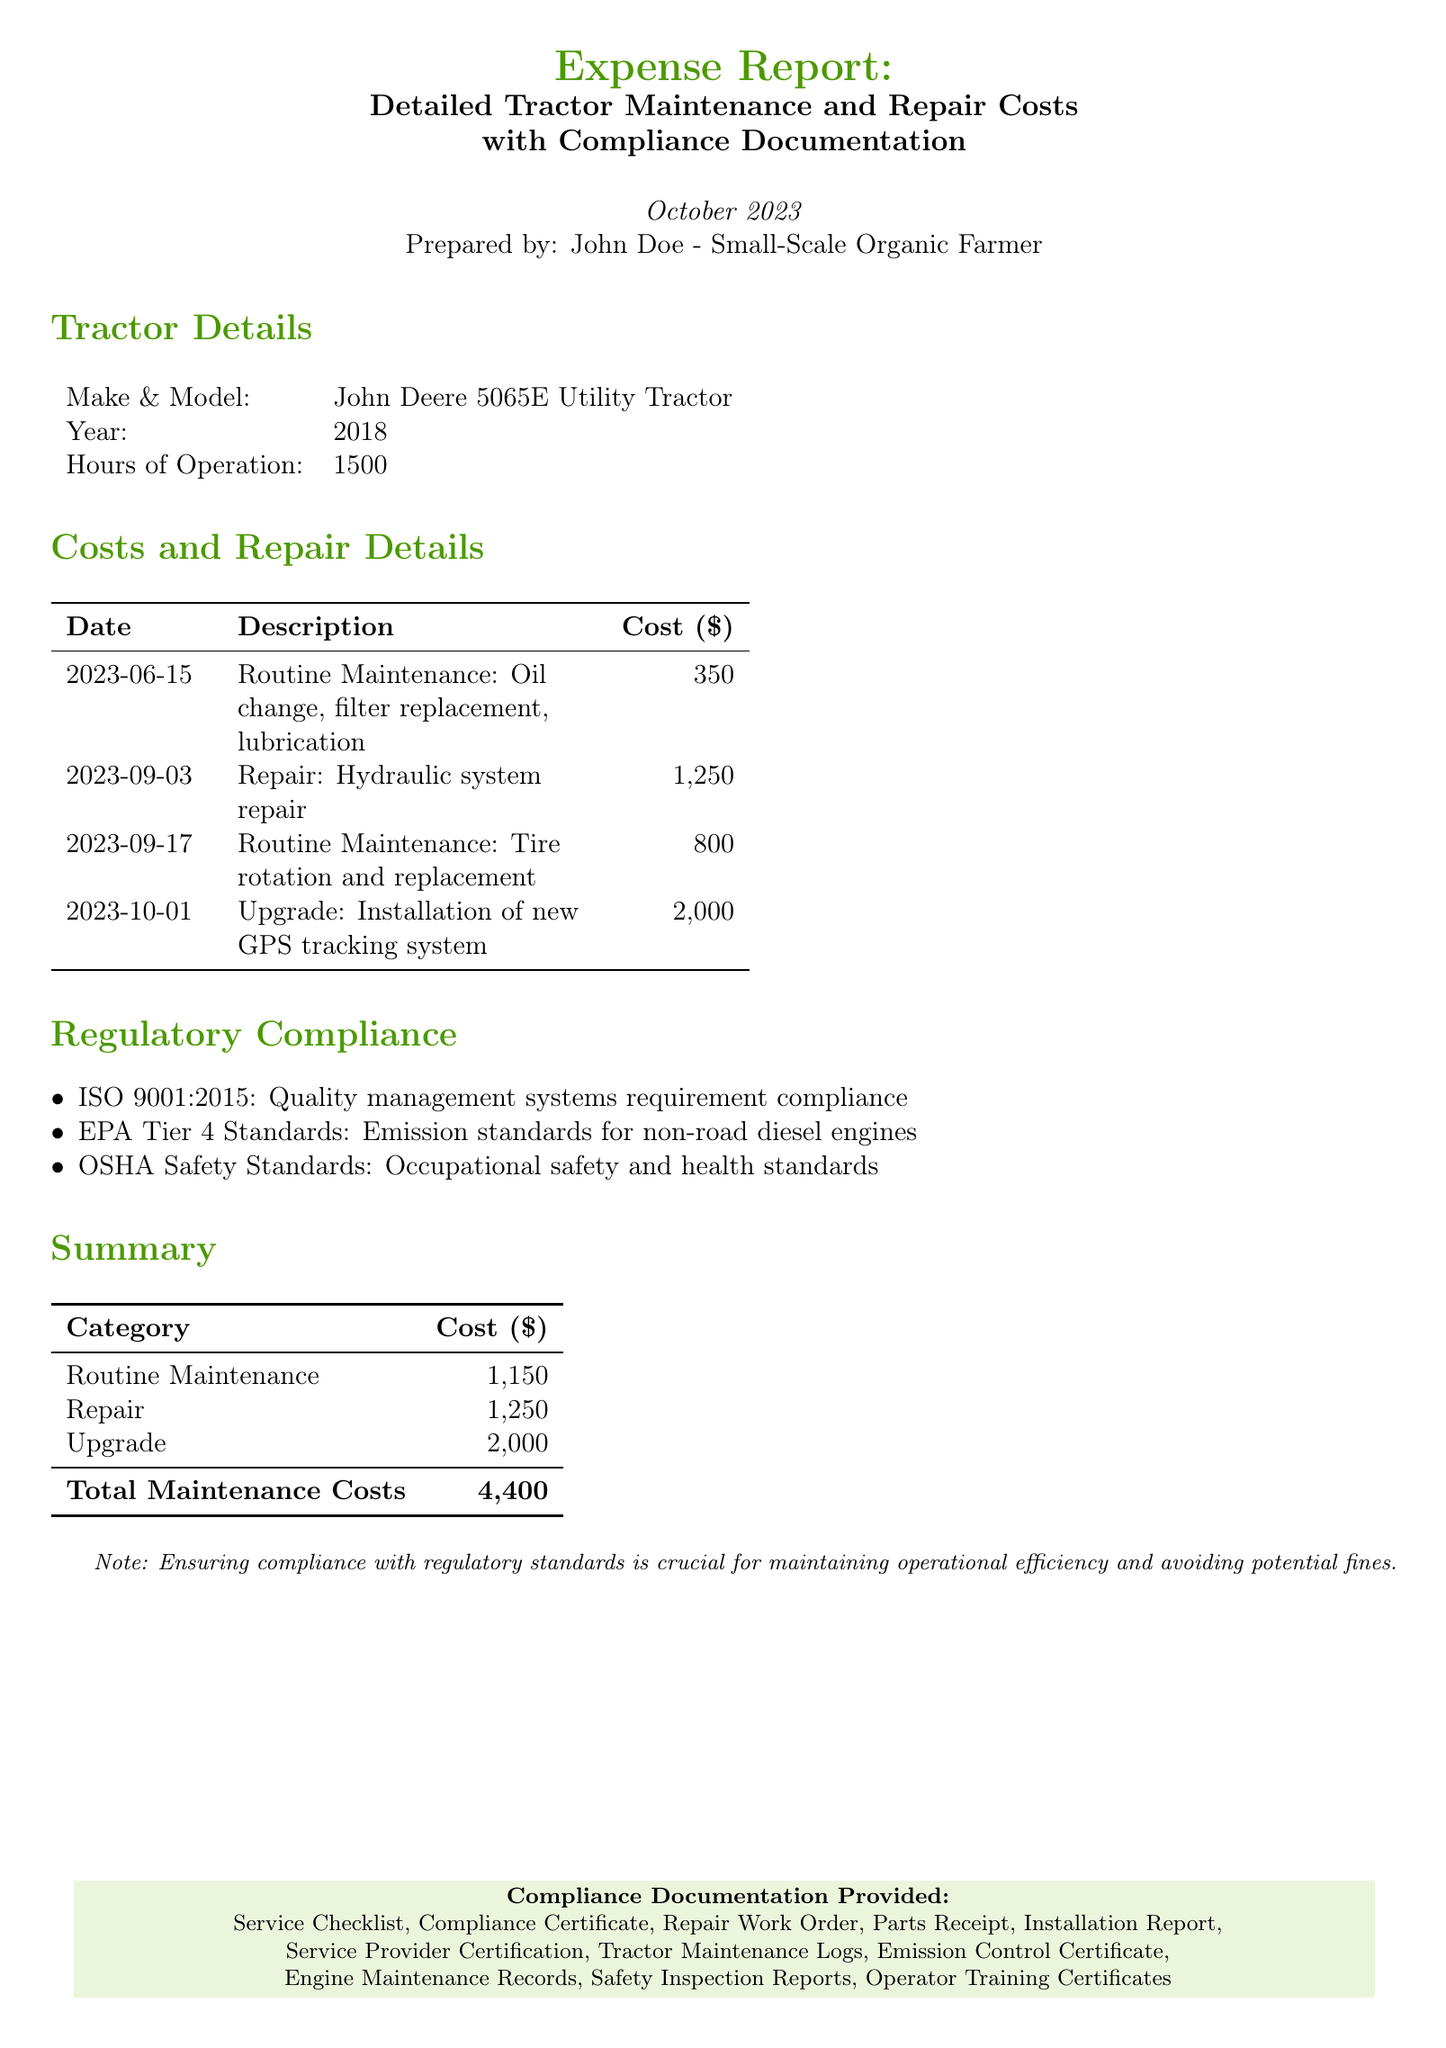What is the total maintenance cost? The total maintenance cost is presented at the end of the document, which adds up the costs from various categories.
Answer: 4,400 What was the cost of the hydraulic system repair? The repair cost specifically for the hydraulic system is listed in the costs and repair details section.
Answer: 1,250 Which tractor model is mentioned in the report? The tractor model is specified at the beginning of the report under the tractor details section.
Answer: John Deere 5065E Utility Tractor What type of maintenance was performed on September 17, 2023? The maintenance type for that date is detailed in the costs and repair details section, referring to actions taken.
Answer: Tire rotation and replacement What compliance standard is related to emission controls? The document lists several compliance standards, with one specifically addressing emissions under regulatory compliance.
Answer: EPA Tier 4 Standards What was the date of the routine maintenance oil change? The specific date for the oil change is noted in the costs and repair details, indicating when that maintenance was performed.
Answer: 2023-06-15 What is the cost of upgrading the GPS tracking system? The upgrade cost is provided in the costs and repair details section, showing the financial expenditure for that specific upgrade.
Answer: 2,000 How many hours of operation does the tractor have? The total hours of operation for the tractor is mentioned in the tractor details section of the document.
Answer: 1500 What type of documentation is provided for compliance? The document concludes with a list of various compliance documents that are provided for verification.
Answer: Service Checklist, Compliance Certificate, Repair Work Order, Parts Receipt, Installation Report, Service Provider Certification, Tractor Maintenance Logs, Emission Control Certificate, Engine Maintenance Records, Safety Inspection Reports, Operator Training Certificates 